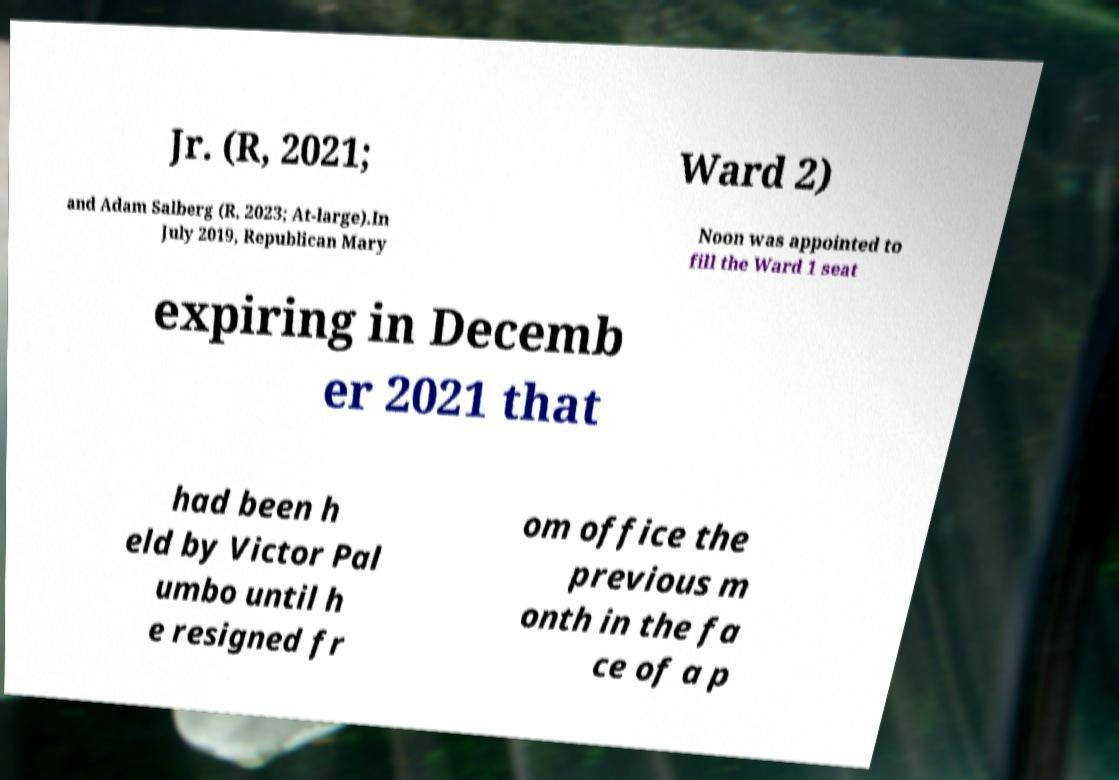I need the written content from this picture converted into text. Can you do that? Jr. (R, 2021; Ward 2) and Adam Salberg (R, 2023; At-large).In July 2019, Republican Mary Noon was appointed to fill the Ward 1 seat expiring in Decemb er 2021 that had been h eld by Victor Pal umbo until h e resigned fr om office the previous m onth in the fa ce of a p 